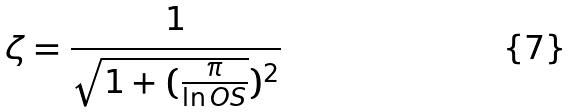<formula> <loc_0><loc_0><loc_500><loc_500>\zeta = \frac { 1 } { \sqrt { 1 + ( \frac { \pi } { \ln O S } } ) ^ { 2 } }</formula> 